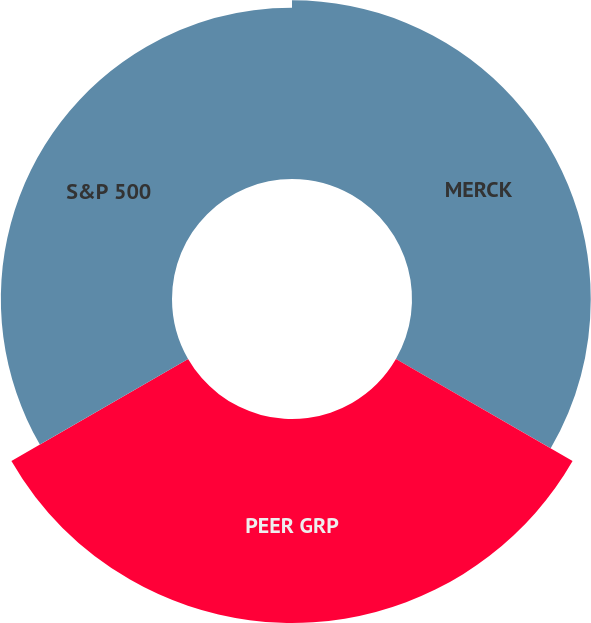<chart> <loc_0><loc_0><loc_500><loc_500><pie_chart><fcel>MERCK<fcel>PEER GRP<fcel>S&P 500<nl><fcel>32.27%<fcel>36.83%<fcel>30.9%<nl></chart> 